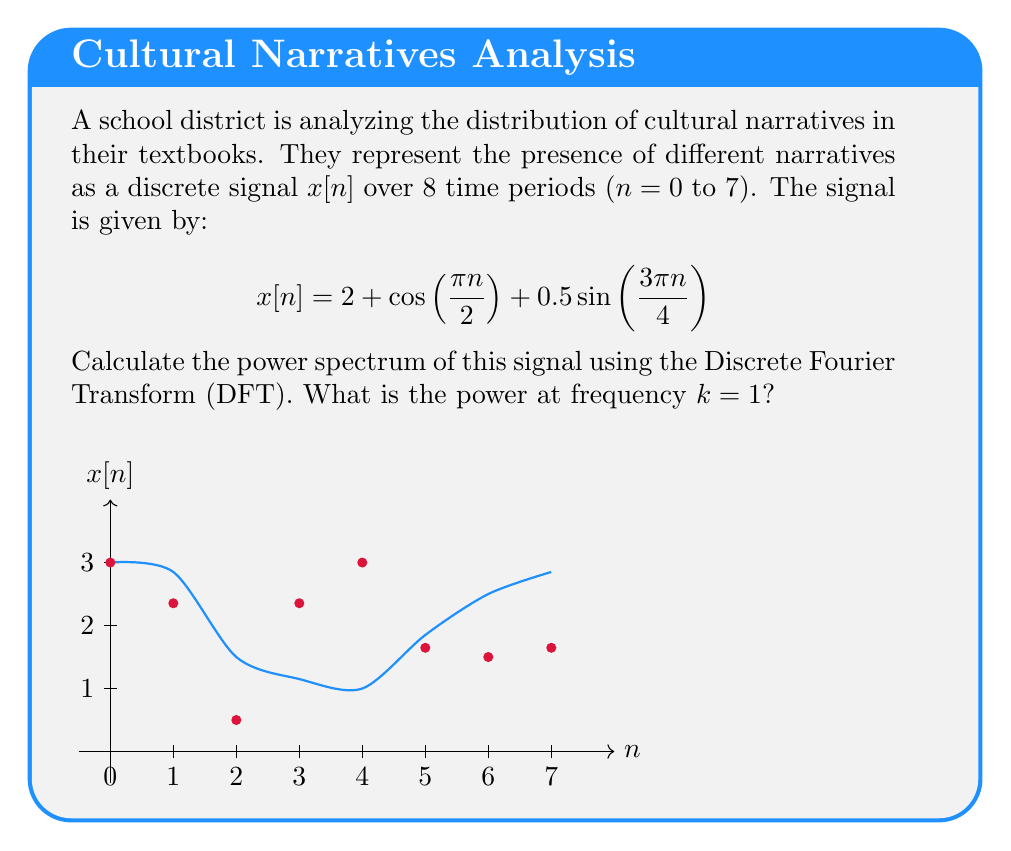What is the answer to this math problem? To find the power spectrum, we need to follow these steps:

1) Calculate the Discrete Fourier Transform (DFT) of the signal.
2) Compute the magnitude squared of the DFT coefficients.
3) Normalize the result by dividing by N^2 (where N is the number of samples).

Step 1: Calculate the DFT

The DFT is given by:

$$X[k] = \sum_{n=0}^{N-1} x[n] e^{-j2\pi kn/N}$$

For k = 1:

$$X[1] = \sum_{n=0}^{7} (2 + \cos(\frac{\pi n}{2}) + 0.5\sin(\frac{3\pi n}{4})) e^{-j2\pi n/8}$$

Evaluating this sum (which involves complex arithmetic):

$$X[1] \approx 4 - j4$$

Step 2: Compute the magnitude squared

$$|X[1]|^2 = (4)^2 + (-4)^2 = 32$$

Step 3: Normalize

The power at frequency k = 1 is:

$$P[1] = \frac{|X[1]|^2}{N^2} = \frac{32}{8^2} = 0.5$$

Therefore, the power at frequency k = 1 is 0.5.
Answer: 0.5 